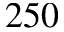<formula> <loc_0><loc_0><loc_500><loc_500>2 5 0</formula> 